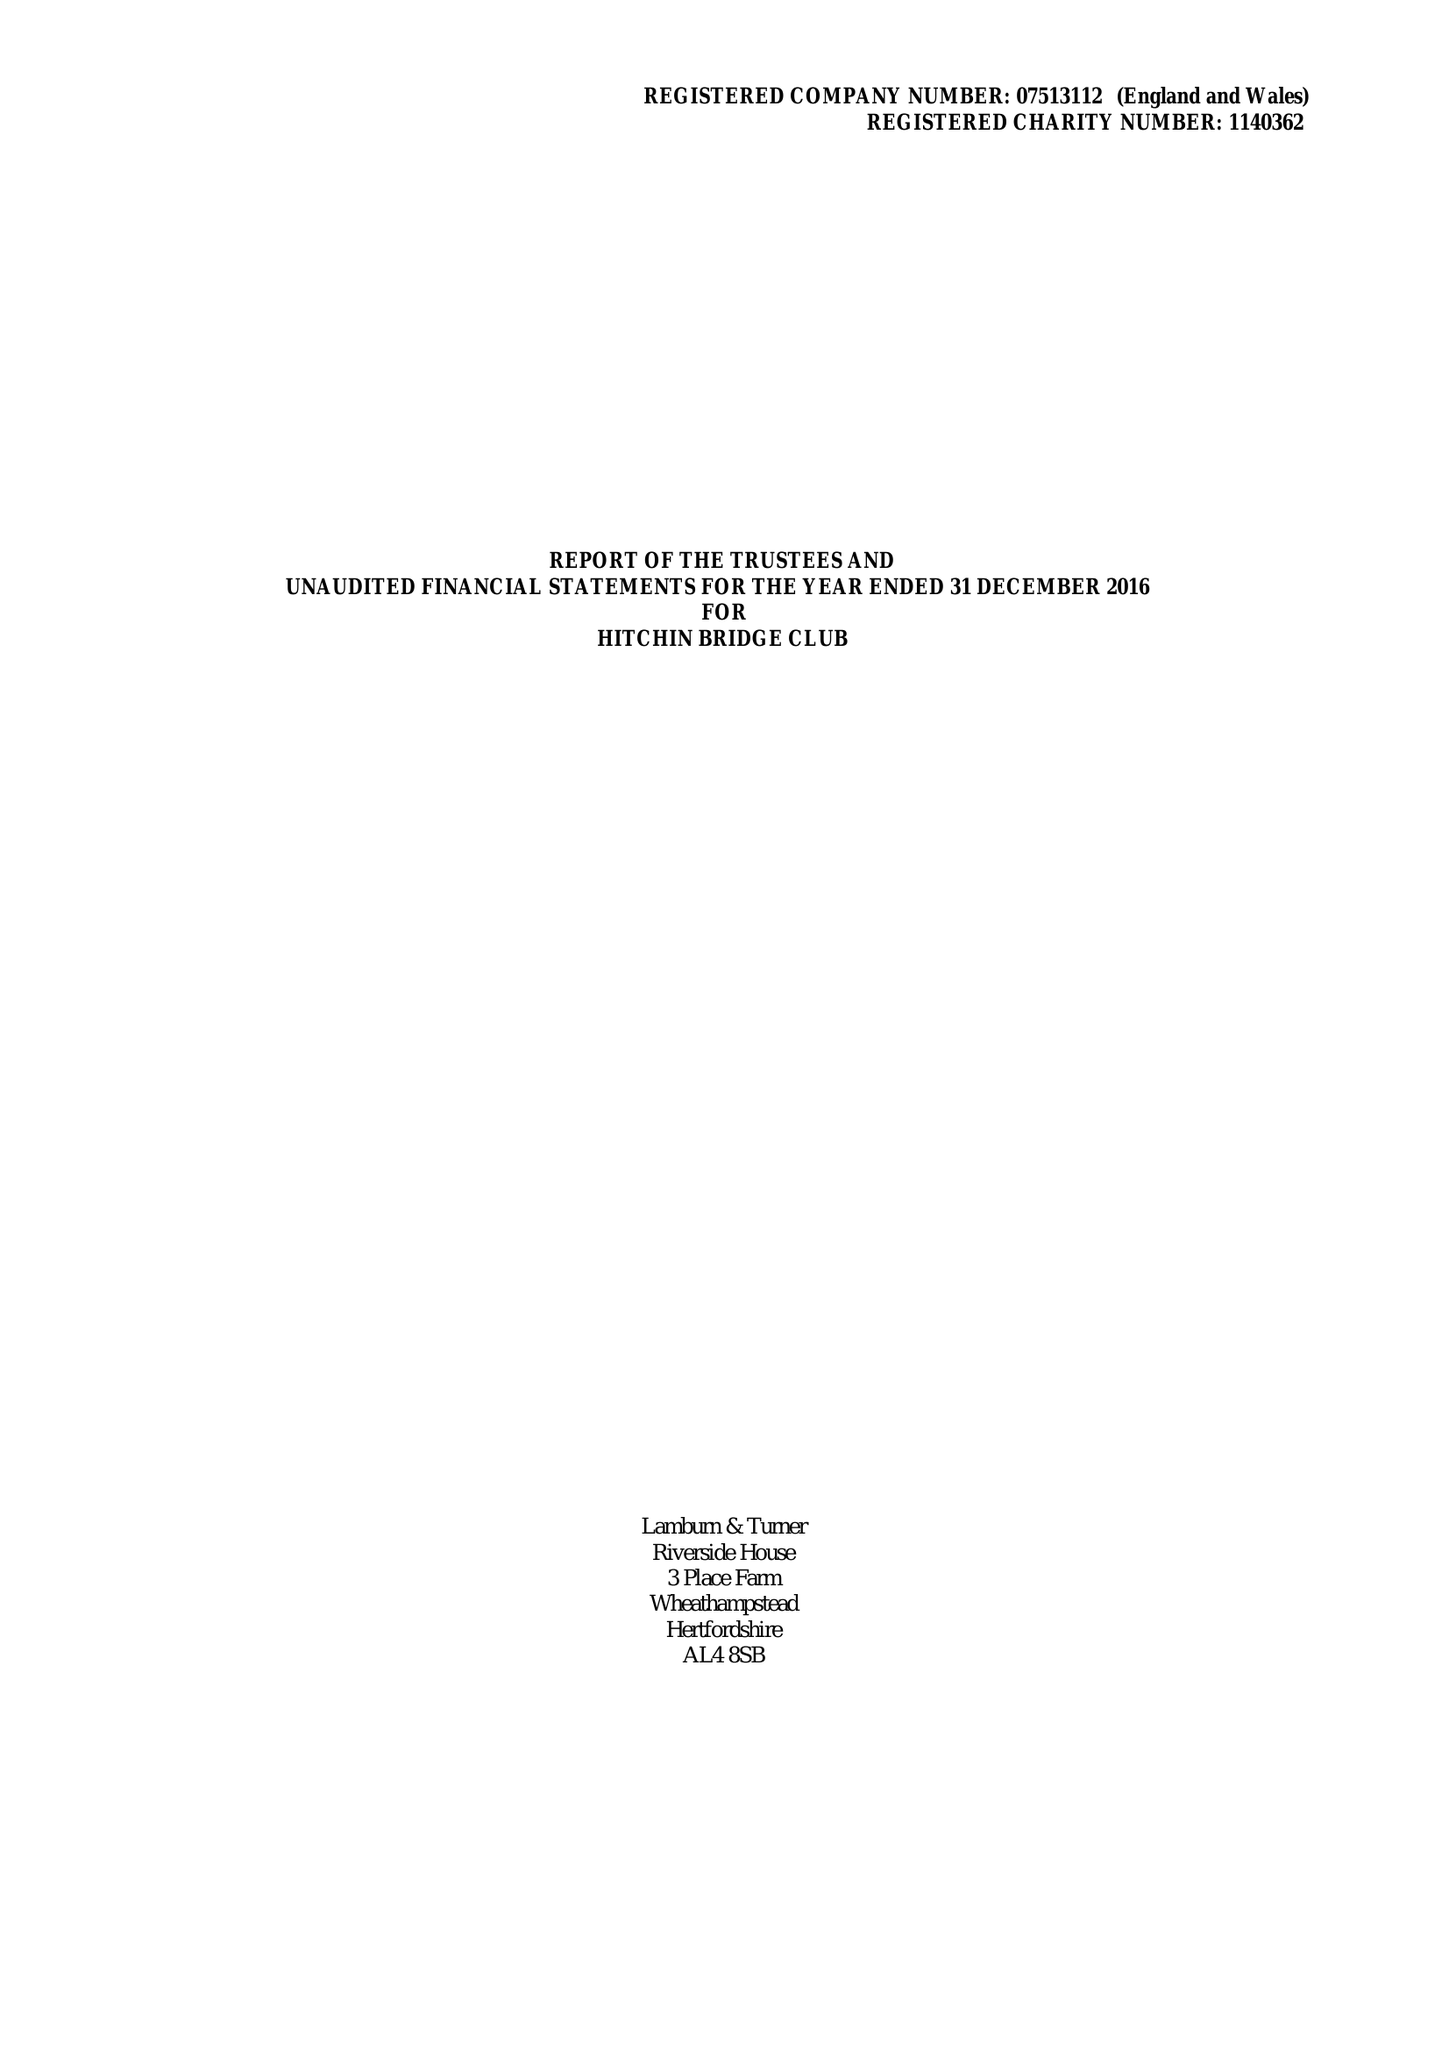What is the value for the report_date?
Answer the question using a single word or phrase. 2016-12-31 